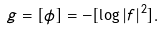Convert formula to latex. <formula><loc_0><loc_0><loc_500><loc_500>g = [ \phi ] = - [ \log | f | ^ { 2 } ] .</formula> 